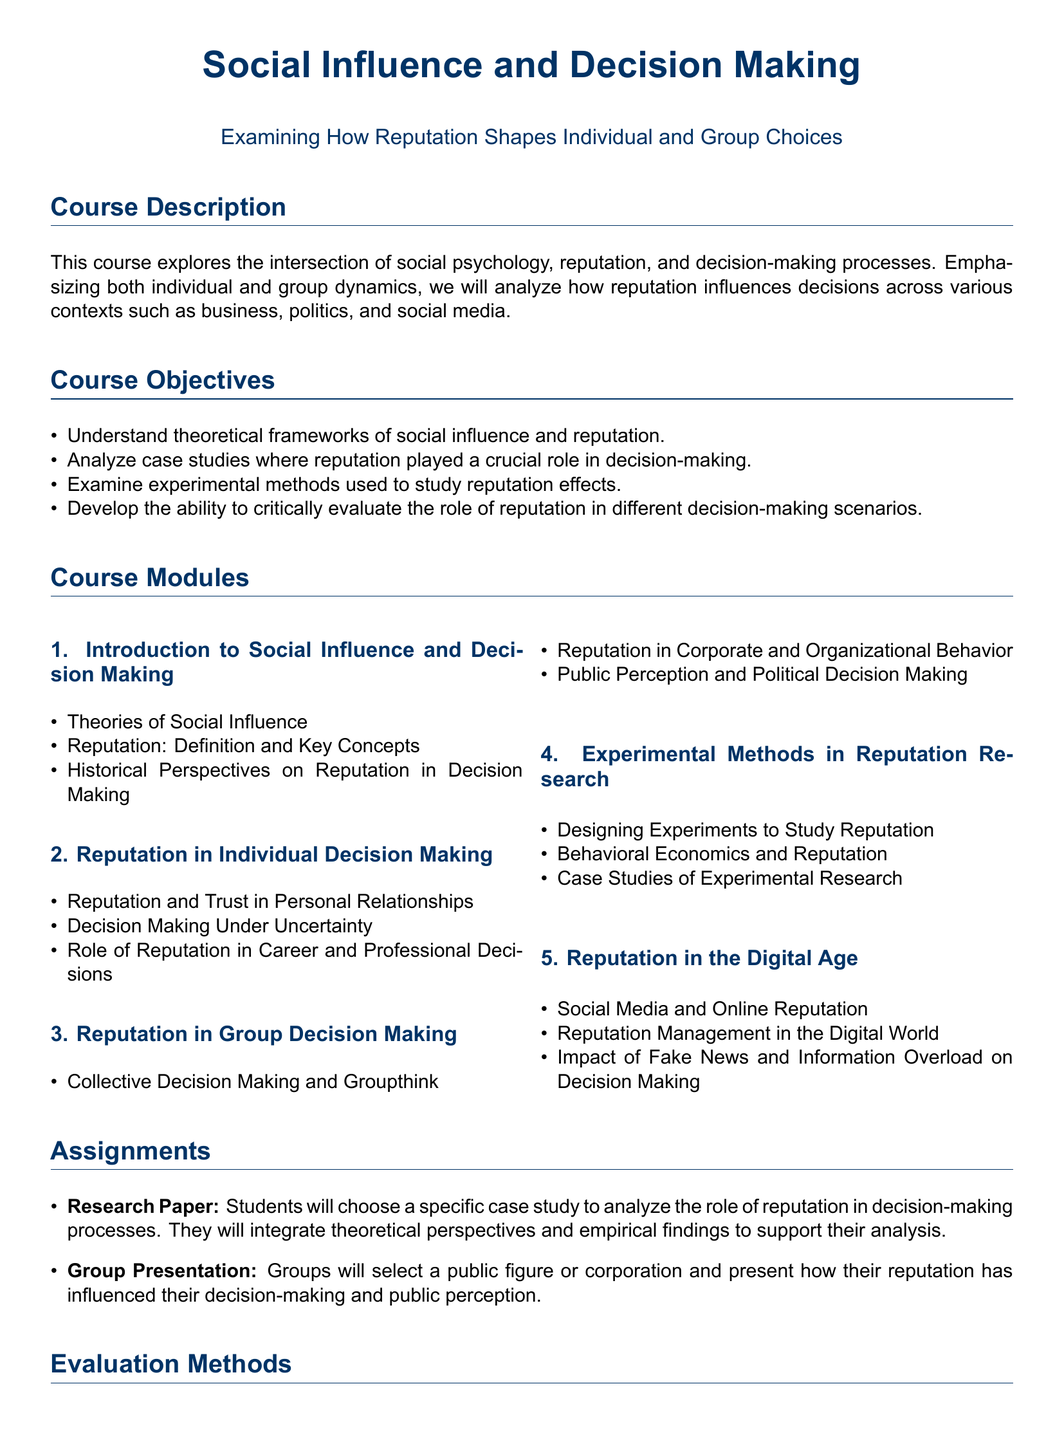What is the main focus of the course? The course focuses on the intersection of social psychology, reputation, and decision-making processes.
Answer: Intersection of social psychology, reputation, and decision-making processes How many course modules are there? The syllabus outlines a total of five course modules.
Answer: Five What percentage of the evaluation is based on quizzes and exams? The quizzes and exams contribute 30 percent to the overall evaluation.
Answer: 30% What is the title of the first course module? The first module is titled "Introduction to Social Influence and Decision Making."
Answer: Introduction to Social Influence and Decision Making What are the recommended prerequisites for the course? The recommended prerequisites are Introduction to Social Psychology and Research Methods in Psychology.
Answer: Introduction to Social Psychology, Research Methods in Psychology What type of assignment requires students to analyze a specific case study? The Research Paper assignment involves analysis of a specific case study.
Answer: Research Paper 